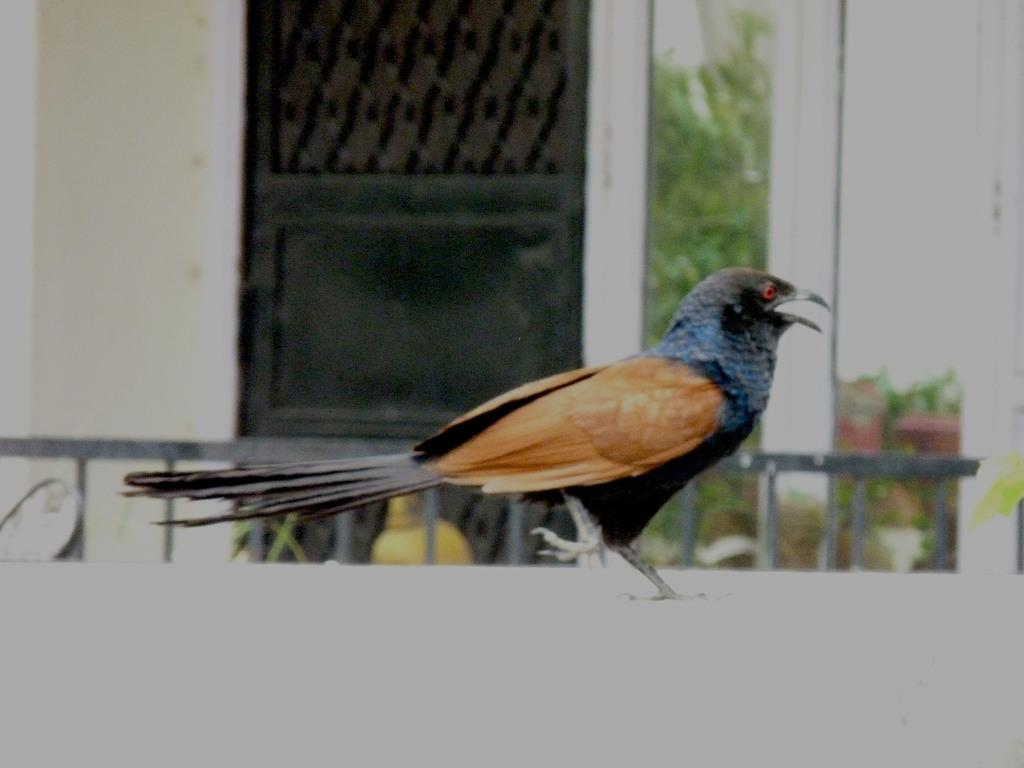What type of animal can be seen in the image? There is a bird in the image. What can be seen in the background of the image? There are metal rods, plants, and a black door in the background of the image. Can you see a lake in the background of the image? No, there is no lake visible in the image. What type of country is depicted in the image? The image does not depict a country; it features a bird and various background elements. 